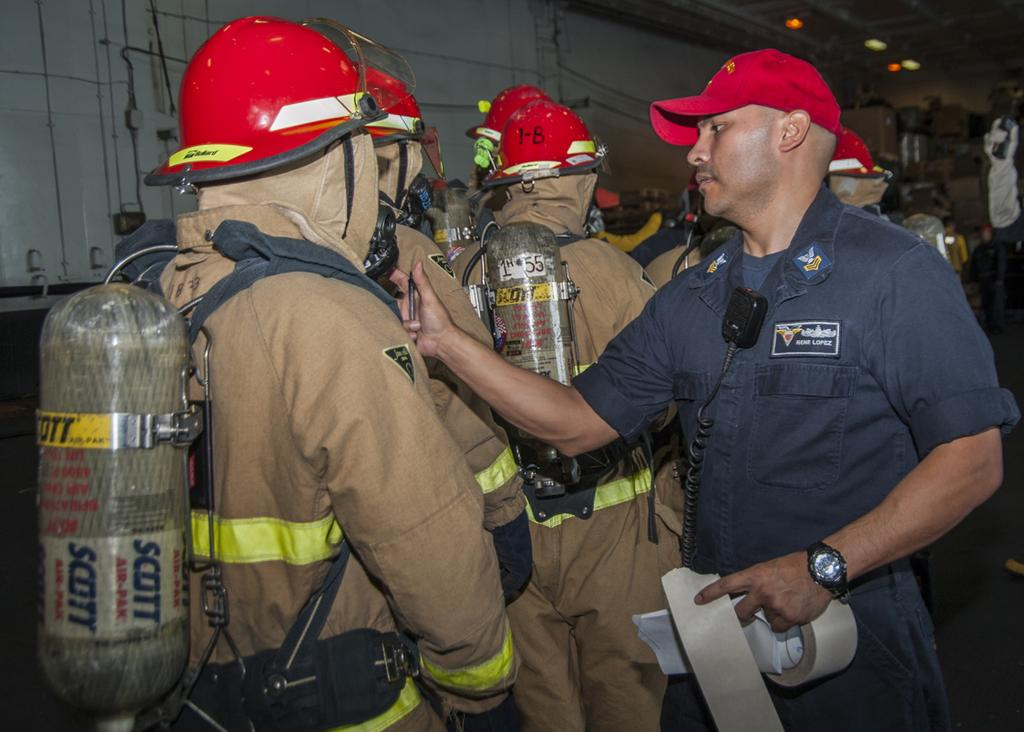What type of people can be seen in the image? There are men in the image. What are the men carrying on their backs? The men are carrying cylinders on their backs. What type of headgear are the men wearing? The men are wearing red helmets. What can be seen in the background of the image? There is a wall in the background of the image. What type of volcanic activity can be seen in the image? There is no volcanic activity present in the image. The men are carrying cylinders on their backs, and there is a wall in the background, but no volcano or related activity is depicted. 